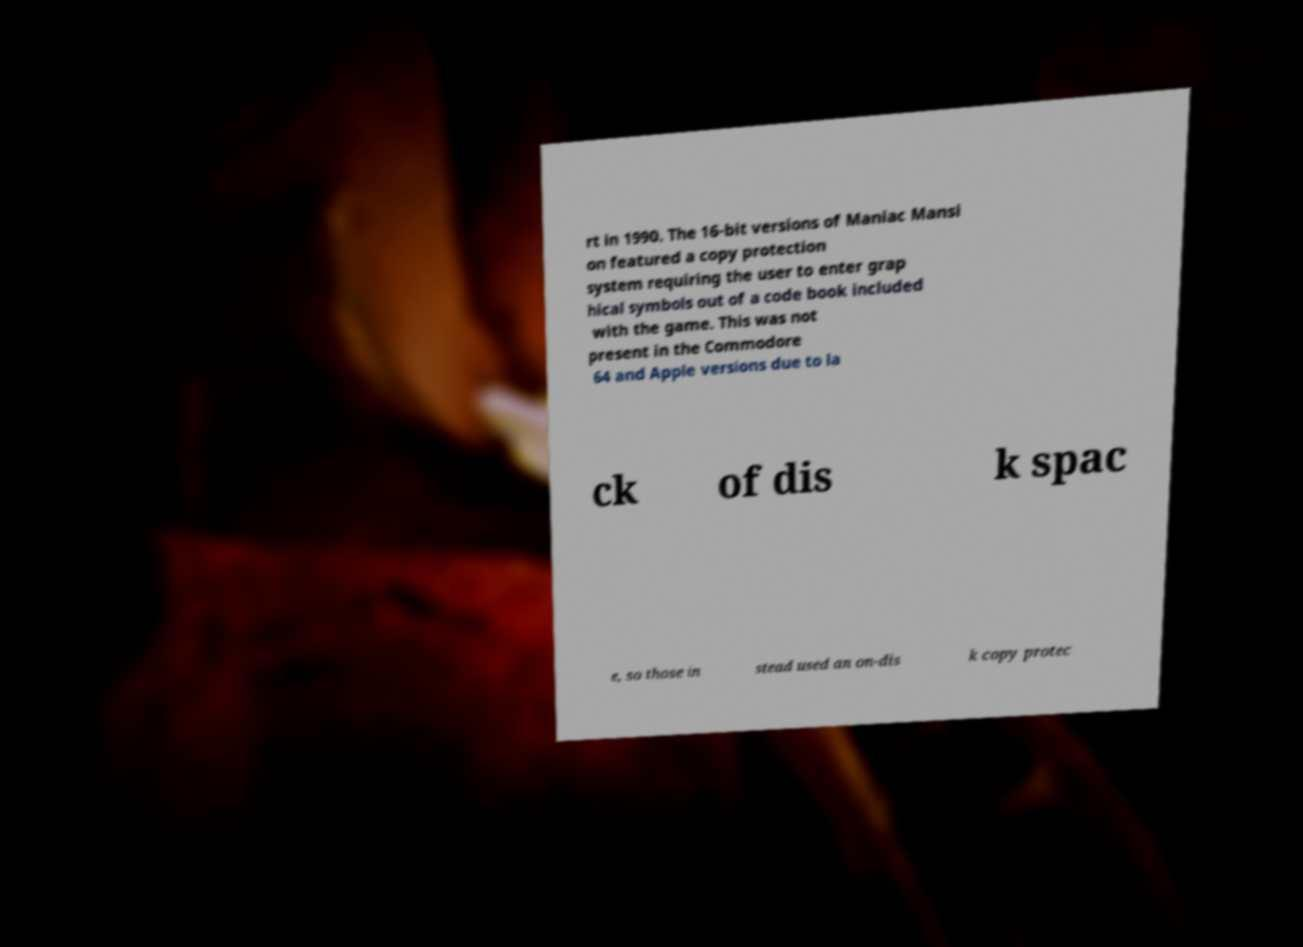Could you assist in decoding the text presented in this image and type it out clearly? rt in 1990. The 16-bit versions of Maniac Mansi on featured a copy protection system requiring the user to enter grap hical symbols out of a code book included with the game. This was not present in the Commodore 64 and Apple versions due to la ck of dis k spac e, so those in stead used an on-dis k copy protec 